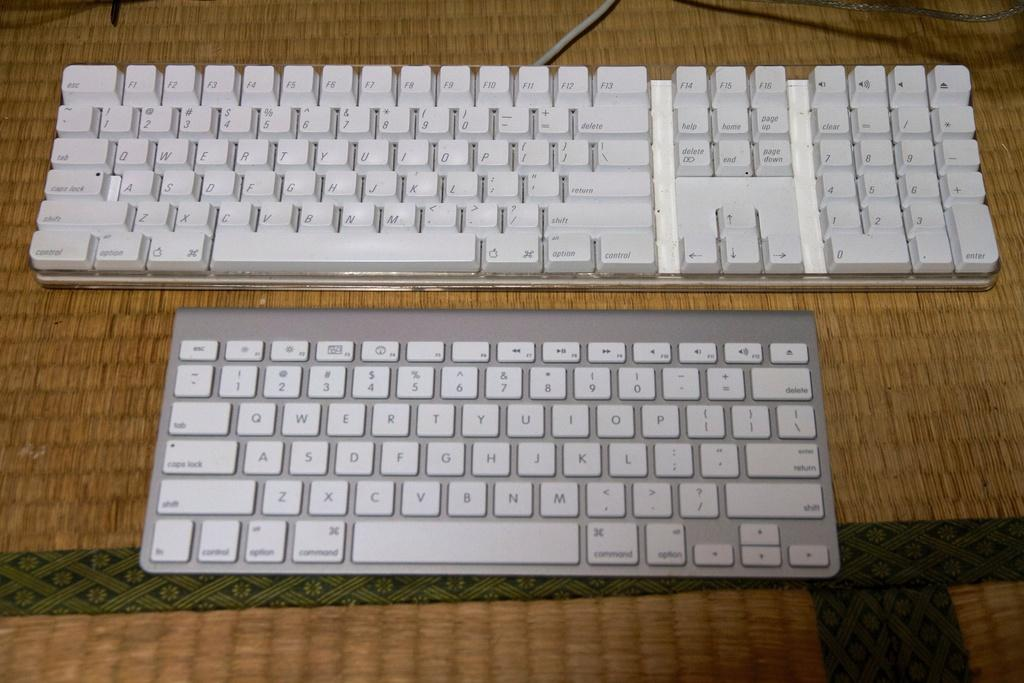<image>
Write a terse but informative summary of the picture. A large white keyboard is next to a smaller silver keyboard that has a key that says command. 